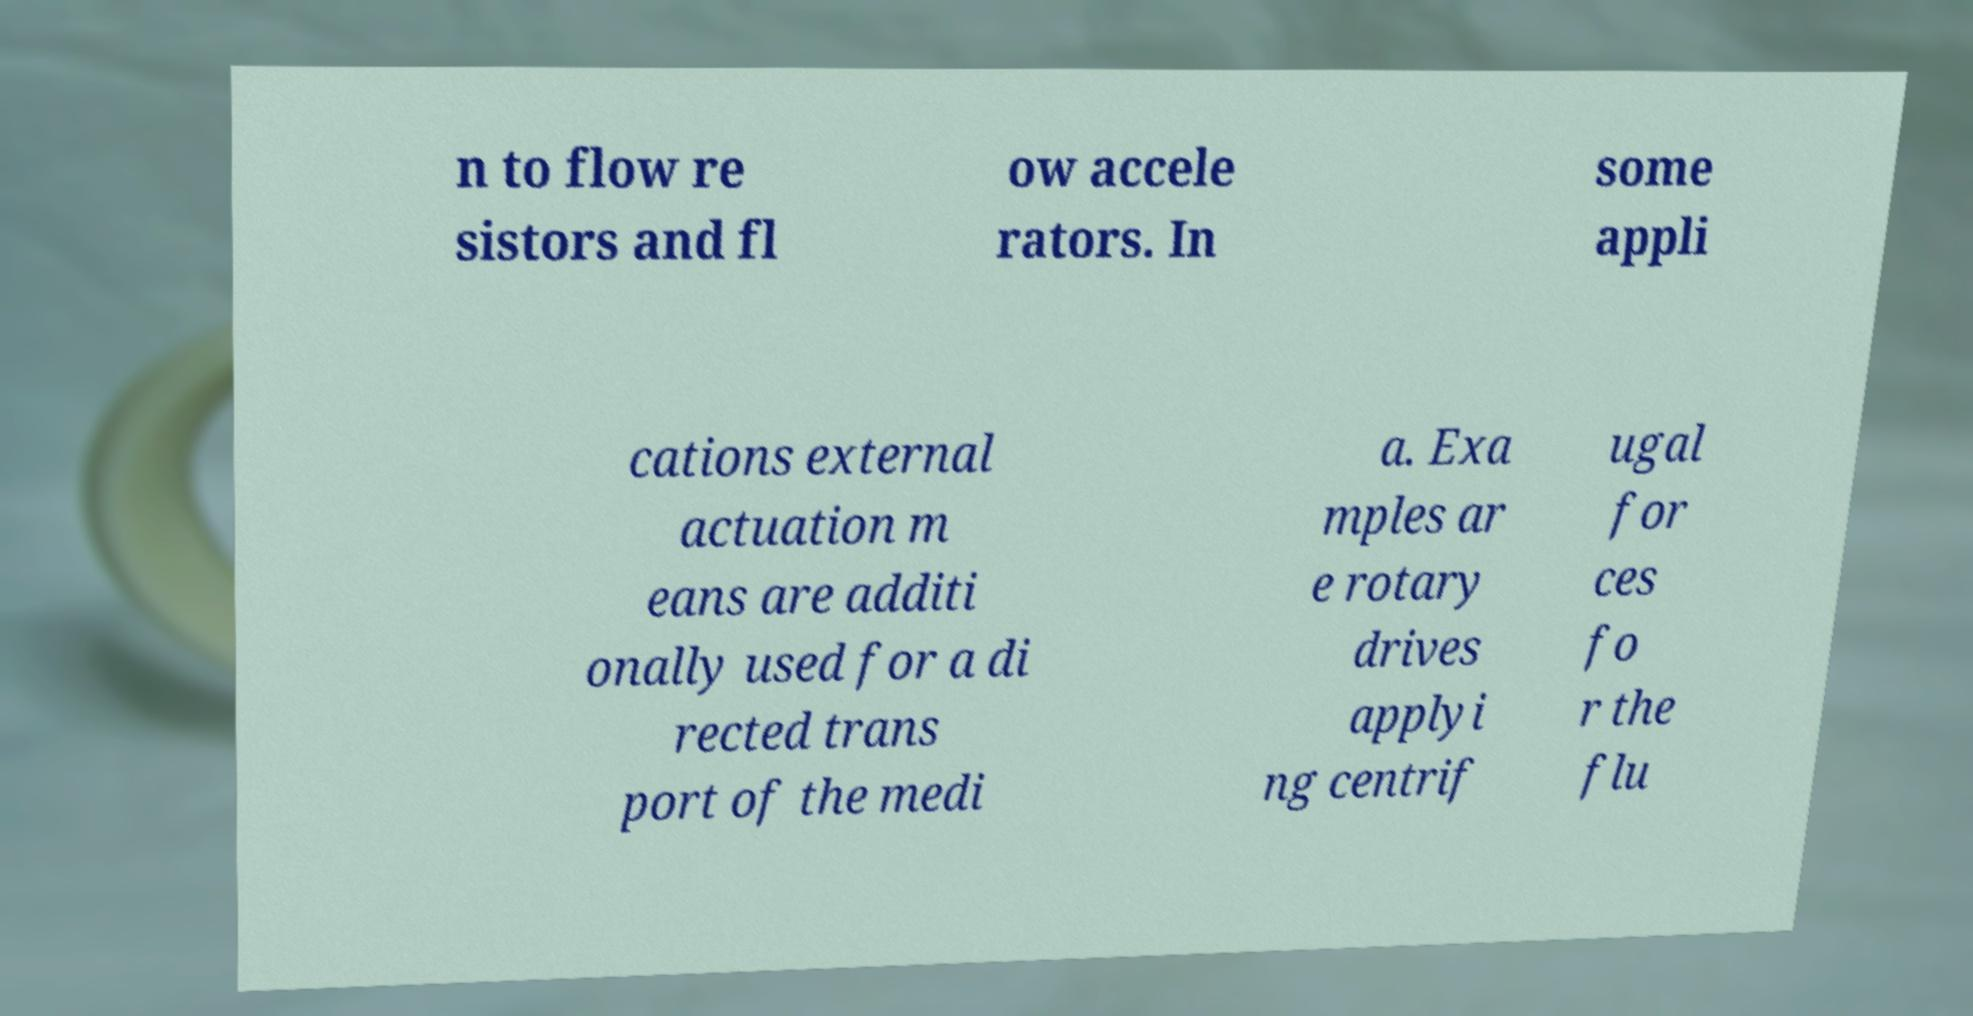What messages or text are displayed in this image? I need them in a readable, typed format. n to flow re sistors and fl ow accele rators. In some appli cations external actuation m eans are additi onally used for a di rected trans port of the medi a. Exa mples ar e rotary drives applyi ng centrif ugal for ces fo r the flu 